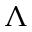Convert formula to latex. <formula><loc_0><loc_0><loc_500><loc_500>\Lambda</formula> 